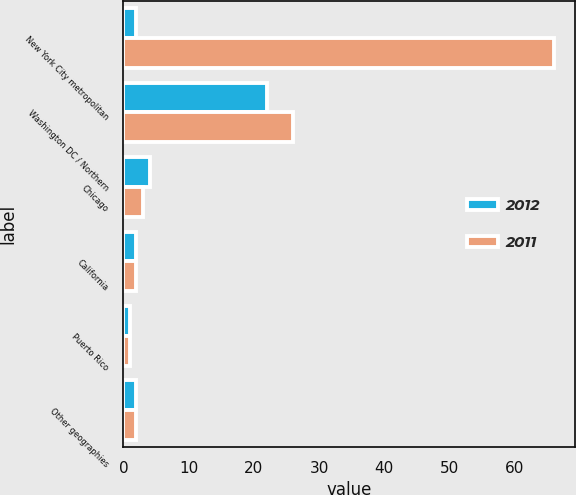<chart> <loc_0><loc_0><loc_500><loc_500><stacked_bar_chart><ecel><fcel>New York City metropolitan<fcel>Washington DC / Northern<fcel>Chicago<fcel>California<fcel>Puerto Rico<fcel>Other geographies<nl><fcel>2012<fcel>2<fcel>22<fcel>4<fcel>2<fcel>1<fcel>2<nl><fcel>2011<fcel>66<fcel>26<fcel>3<fcel>2<fcel>1<fcel>2<nl></chart> 